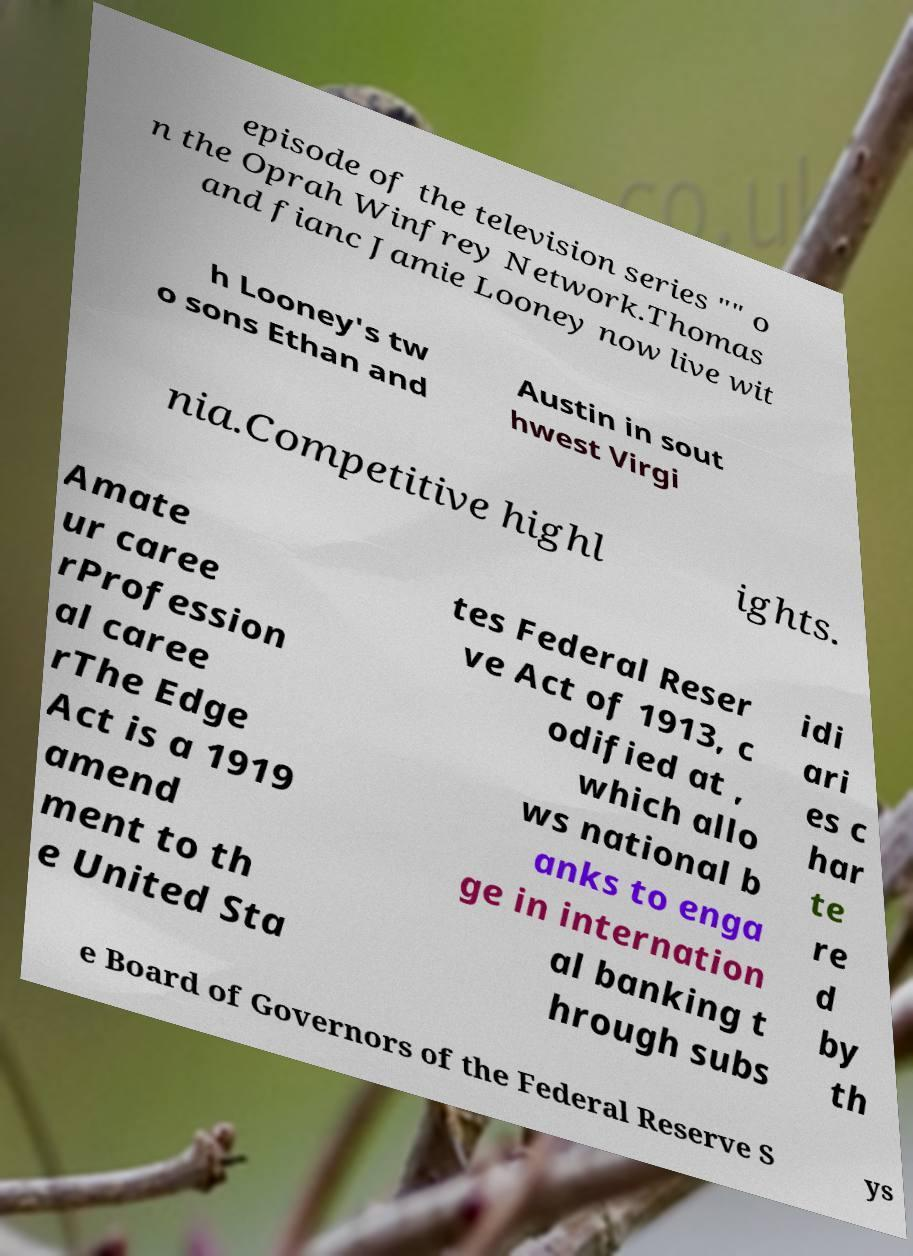I need the written content from this picture converted into text. Can you do that? episode of the television series "" o n the Oprah Winfrey Network.Thomas and fianc Jamie Looney now live wit h Looney's tw o sons Ethan and Austin in sout hwest Virgi nia.Competitive highl ights. Amate ur caree rProfession al caree rThe Edge Act is a 1919 amend ment to th e United Sta tes Federal Reser ve Act of 1913, c odified at , which allo ws national b anks to enga ge in internation al banking t hrough subs idi ari es c har te re d by th e Board of Governors of the Federal Reserve S ys 